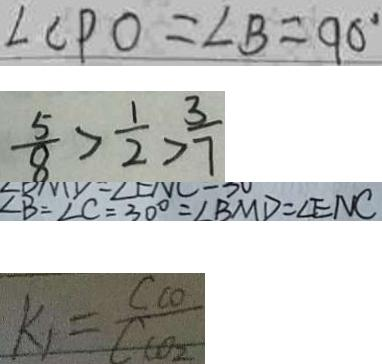<formula> <loc_0><loc_0><loc_500><loc_500>\angle C P O = \angle B = 9 0 ^ { \circ } 
 \frac { 5 } { 8 } > \frac { 1 } { 2 } > \frac { 3 } { 7 } 
 \angle B = \angle C = 3 0 ^ { \circ } = \angle B M D = \angle E N C 
 k _ { 1 } = \frac { C c o } { C c o _ { 2 } }</formula> 